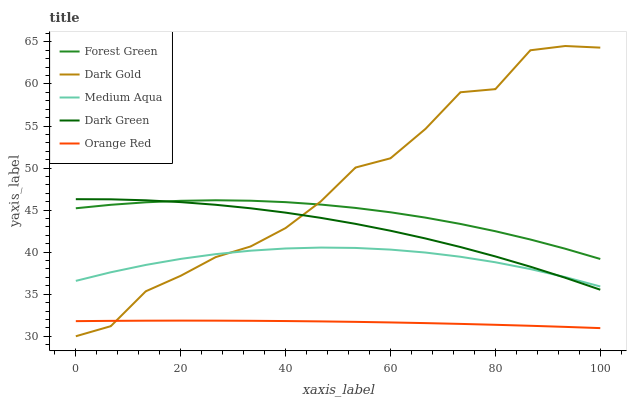Does Dark Green have the minimum area under the curve?
Answer yes or no. No. Does Dark Green have the maximum area under the curve?
Answer yes or no. No. Is Dark Green the smoothest?
Answer yes or no. No. Is Dark Green the roughest?
Answer yes or no. No. Does Dark Green have the lowest value?
Answer yes or no. No. Does Dark Green have the highest value?
Answer yes or no. No. Is Orange Red less than Forest Green?
Answer yes or no. Yes. Is Forest Green greater than Medium Aqua?
Answer yes or no. Yes. Does Orange Red intersect Forest Green?
Answer yes or no. No. 